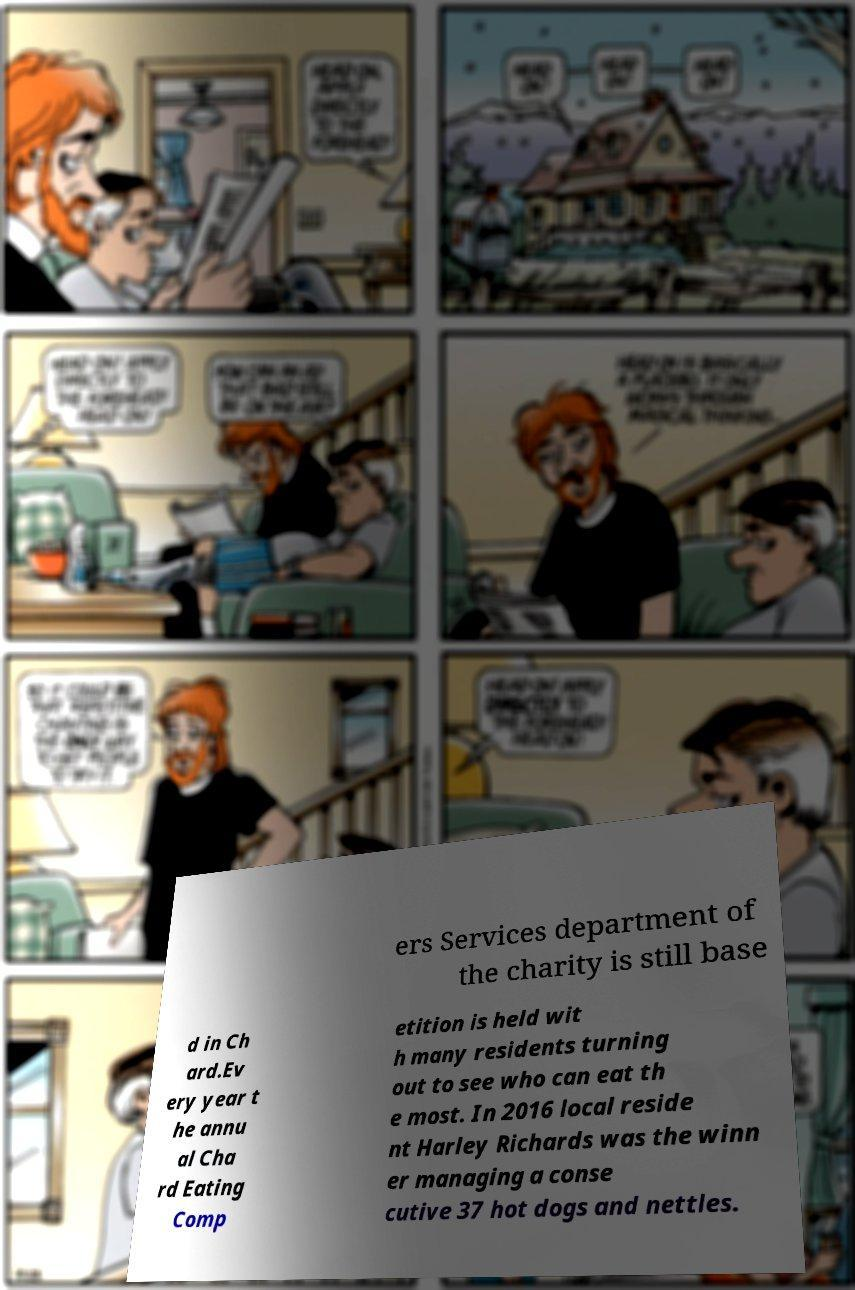There's text embedded in this image that I need extracted. Can you transcribe it verbatim? ers Services department of the charity is still base d in Ch ard.Ev ery year t he annu al Cha rd Eating Comp etition is held wit h many residents turning out to see who can eat th e most. In 2016 local reside nt Harley Richards was the winn er managing a conse cutive 37 hot dogs and nettles. 